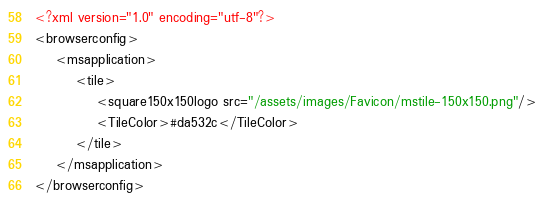<code> <loc_0><loc_0><loc_500><loc_500><_XML_><?xml version="1.0" encoding="utf-8"?>
<browserconfig>
    <msapplication>
        <tile>
            <square150x150logo src="/assets/images/Favicon/mstile-150x150.png"/>
            <TileColor>#da532c</TileColor>
        </tile>
    </msapplication>
</browserconfig>
</code> 